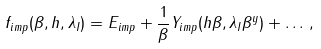Convert formula to latex. <formula><loc_0><loc_0><loc_500><loc_500>f _ { i m p } ( \beta , h , \lambda _ { I } ) = E _ { i m p } + \frac { 1 } { \beta } Y _ { i m p } ( h \beta , \lambda _ { I } \beta ^ { y } ) + \dots \, ,</formula> 